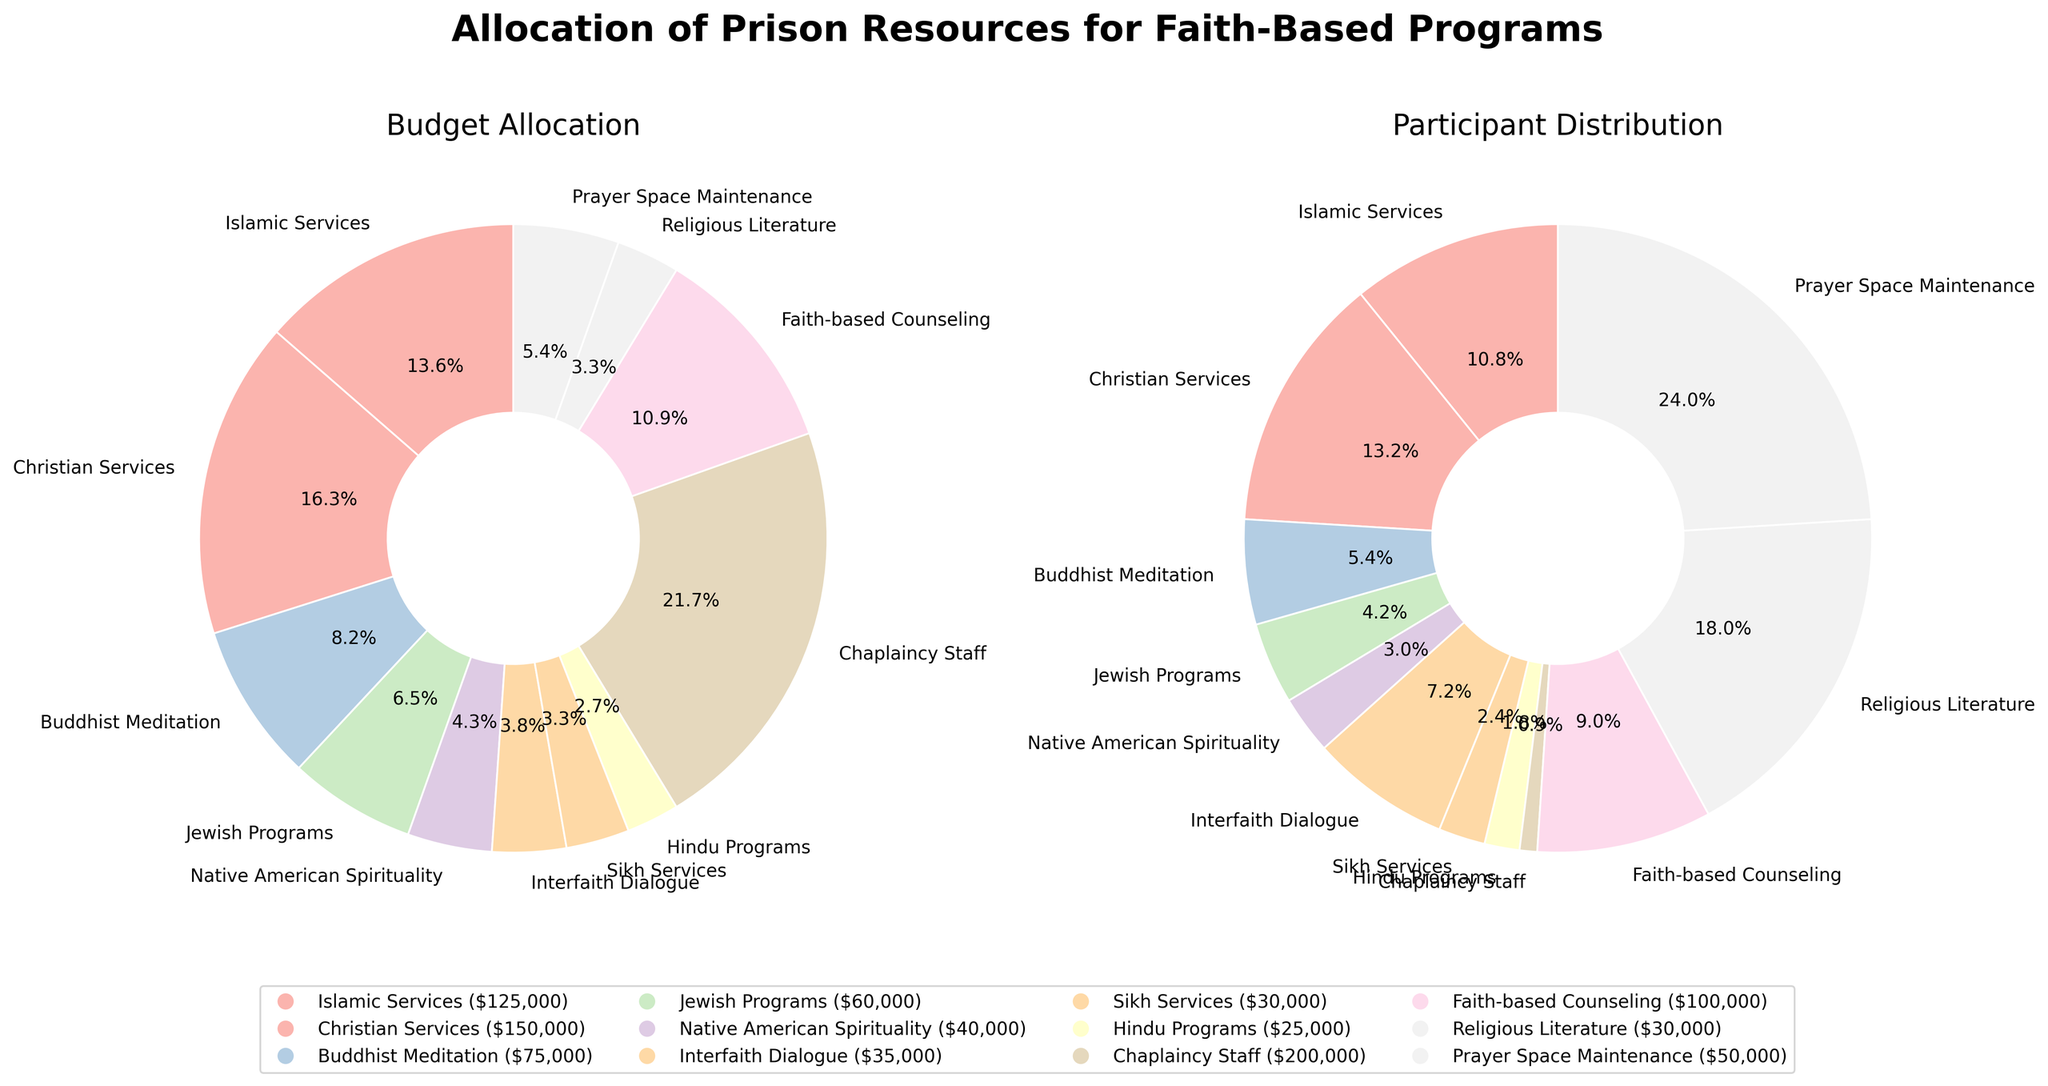What is the title of the figure? The title is displayed at the top of the figure and describes the overall content. It reads "Allocation of Prison Resources for Faith-Based Programs."
Answer: Allocation of Prison Resources for Faith-Based Programs Which program has the largest budget allocation? By examining the Budget Allocation pie chart, we see that the largest slice corresponds to "Chaplaincy Staff." The legend also indicates the budget amount with "$200,000."
Answer: Chaplaincy Staff How many participants are there in the Native American Spirituality program? The Participants pie chart has a slice labeled "Native American Spirituality," which shows "50" participants.
Answer: 50 What percentage of the budget is allocated to Christian Services? In the Budget Allocation pie chart, the slice for "Christian Services" shows a percentage label, which reads "15.0%."
Answer: 15.0% Compare the number of participants in Islamic Services and Faith-based Counseling. Which program has more participants? By inspecting the Participants pie chart, the slices for "Islamic Services" and "Faith-based Counseling" show "180" and "150" participants, respectively. This means Islamic Services has more participants.
Answer: Islamic Services What is the sum of the budgets allocated to Buddhist Meditation and Jewish Programs? The Budget Allocation pie chart shows the allocations for "Buddhist Meditation" and "Jewish Programs" as $75,000 and $60,000 respectively. Adding these gives $75,000 + $60,000 = $135,000.
Answer: $135,000 Which program has the smallest number of participants? By looking at the Participants pie chart, the smallest slice corresponds to "Hindu Programs" with "30" participants.
Answer: Hindu Programs How does the budget for Islamic Services compare to that for Christian Services? The Budget Allocation pie chart shows Islamic Services with a slice labeled "$125,000" and Christian Services with "$150,000". Christian Services therefore has a larger budget.
Answer: Christian Services has a larger budget What is the combined percentage of the budget allocated to Interfaith Dialogue and Sikh Services? The Budget Allocation pie chart indicates "Interfaith Dialogue" with 3.5% and "Sikh Services" with 3.0%. Adding these gives 3.5% + 3.0% = 6.5%.
Answer: 6.5% Which three programs have the largest number of participants? The Participants pie chart shows the largest slices for "Prayer Space Maintenance" (400), "Religious Literature" (300), and "Christian Services" (220).
Answer: Prayer Space Maintenance, Religious Literature, Christian Services 